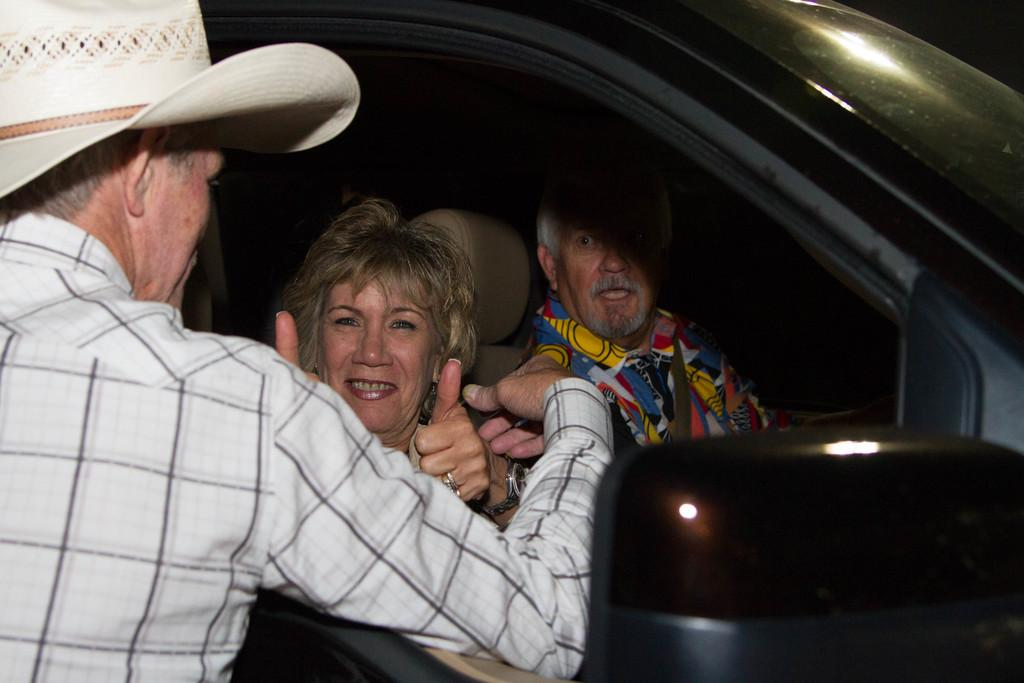How many people are in the image? There are three persons in the image. What are two of the persons doing in the image? Two of the persons are sitting in a car. Can you describe the appearance of one of the persons? One person is wearing a hat. What part of the car can be seen in the image? There is a side mirror visible in the image. What type of force is being applied to the car in the image? There is no indication of any force being applied to the car in the image. Can you describe the pest problem in the image? There is no mention of any pest problem in the image. 